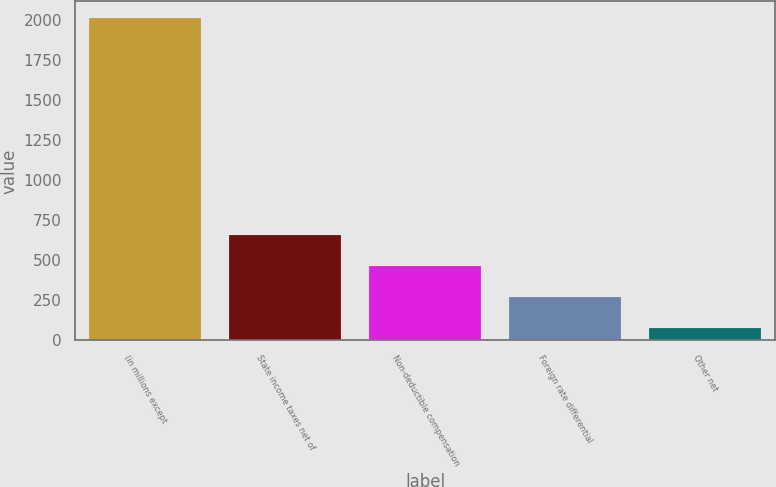Convert chart. <chart><loc_0><loc_0><loc_500><loc_500><bar_chart><fcel>(in millions except<fcel>State income taxes net of<fcel>Non-deductible compensation<fcel>Foreign rate differential<fcel>Other net<nl><fcel>2016<fcel>658.7<fcel>464.8<fcel>270.9<fcel>77<nl></chart> 